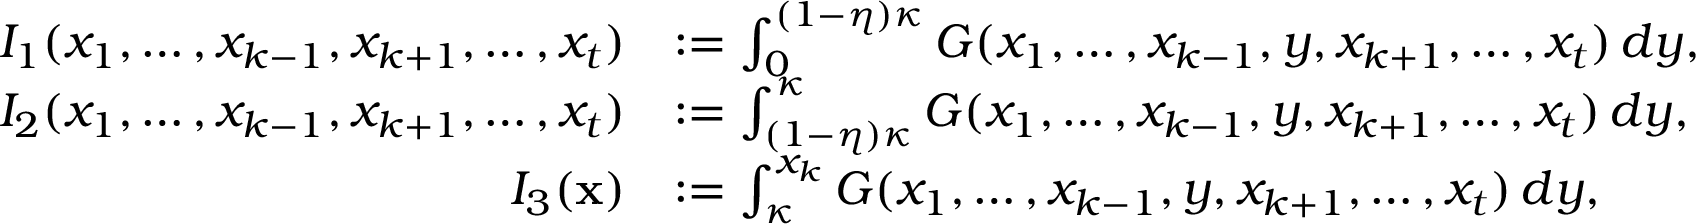<formula> <loc_0><loc_0><loc_500><loc_500>\begin{array} { r l } { I _ { 1 } ( x _ { 1 } , \dots , x _ { k - 1 } , x _ { k + 1 } , \dots , x _ { t } ) } & { \colon = \int _ { 0 } ^ { ( 1 - \eta ) \kappa } G ( x _ { 1 } , \dots , x _ { k - 1 } , y , x _ { k + 1 } , \dots , x _ { t } ) \, d y , } \\ { I _ { 2 } ( x _ { 1 } , \dots , x _ { k - 1 } , x _ { k + 1 } , \dots , x _ { t } ) } & { \colon = \int _ { ( 1 - \eta ) \kappa } ^ { \kappa } G ( x _ { 1 } , \dots , x _ { k - 1 } , y , x _ { k + 1 } , \dots , x _ { t } ) \, d y , } \\ { I _ { 3 } ( x ) } & { \colon = \int _ { \kappa } ^ { x _ { k } } G ( x _ { 1 } , \dots , x _ { k - 1 } , y , x _ { k + 1 } , \dots , x _ { t } ) \, d y , } \end{array}</formula> 